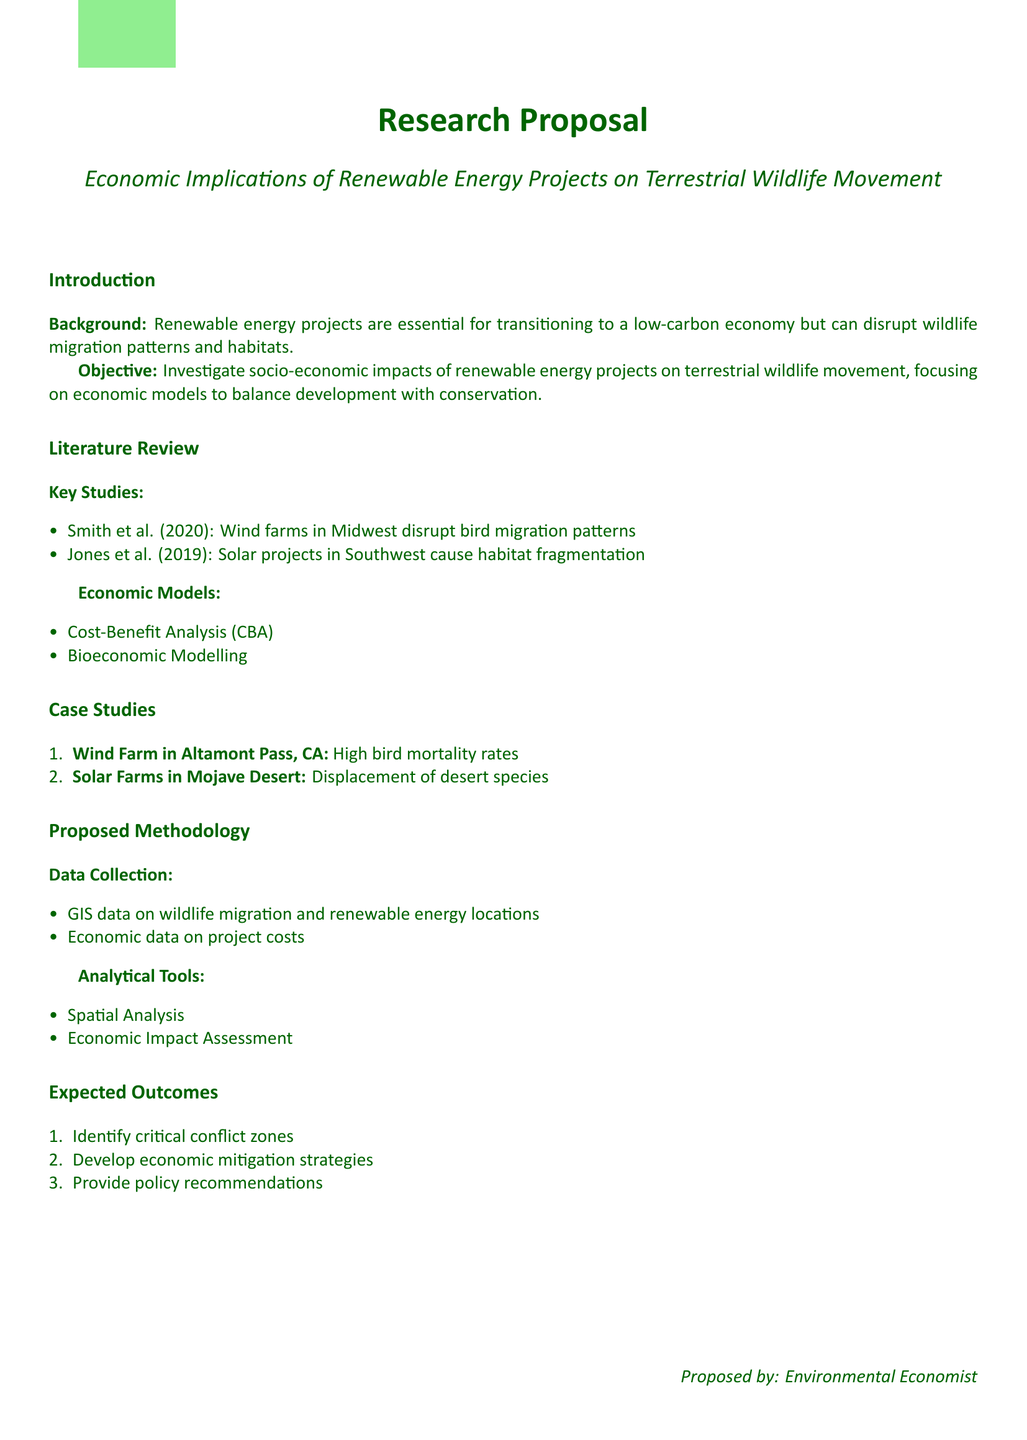What is the research proposal title? The title can be found in the document's main heading, which states the focus of the research.
Answer: Economic Implications of Renewable Energy Projects on Terrestrial Wildlife Movement What are the key studies mentioned? The document lists specific studies related to renewable energy and wildlife in the literature review section.
Answer: Smith et al. (2020) and Jones et al. (2019) Identify the first case study listed. The first case study is clearly outlined in the case studies section, which presents examples of wildlife impact from renewable energy projects.
Answer: Wind Farm in Altamont Pass, CA What economic model is used for analysis? The document lists various economic models employed in the research proposal.
Answer: Cost-Benefit Analysis What type of data will be collected? The document specifies types of data to be gathered for the research methodology.
Answer: GIS data on wildlife migration and renewable energy locations What are the expected outcomes of the research? The expected outcomes are specified in a list form in the proposal, indicating the goals of the study.
Answer: Identify critical conflict zones What analytical tool is mentioned for assessment? The document states specific analytical tools that will be utilized in the proposed methodology section.
Answer: Economic Impact Assessment Who proposed the research? The document provides an indication of the individual or group responsible for the proposal at the end.
Answer: Environmental Economist 